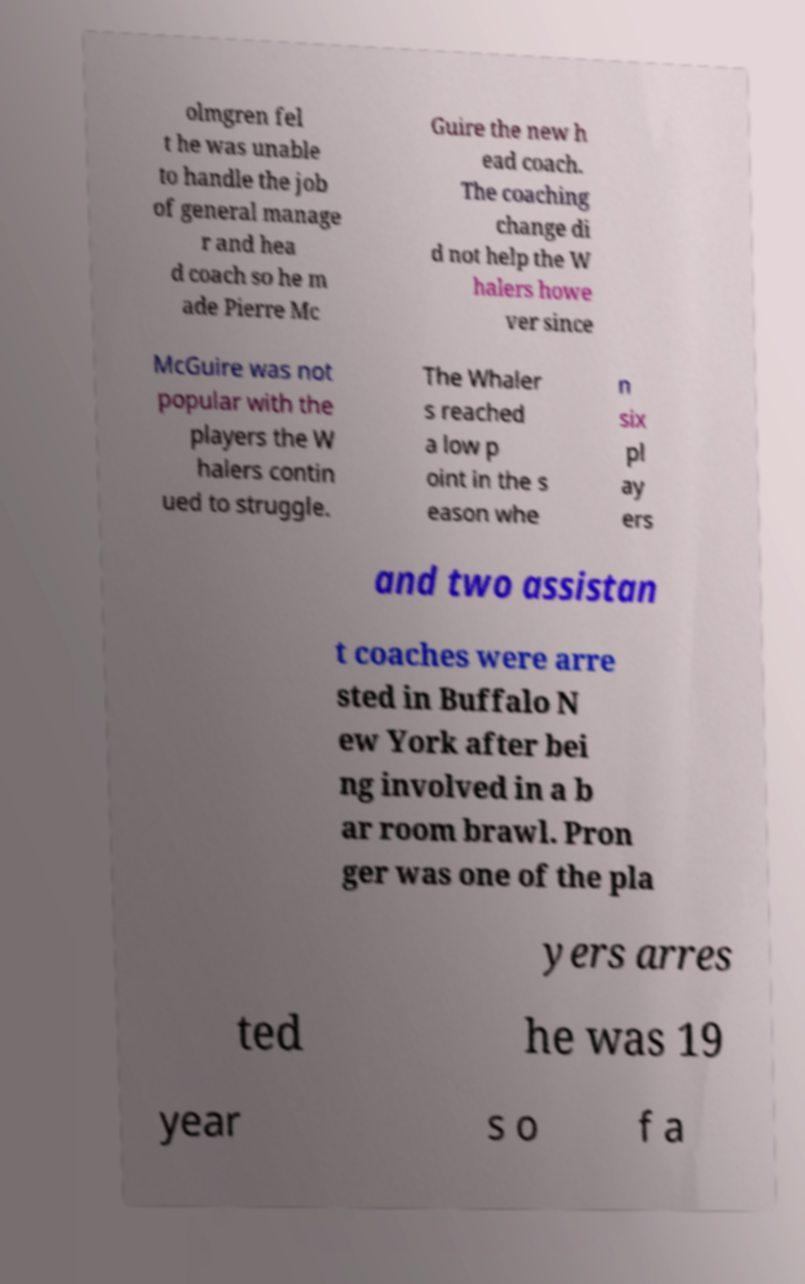Can you accurately transcribe the text from the provided image for me? olmgren fel t he was unable to handle the job of general manage r and hea d coach so he m ade Pierre Mc Guire the new h ead coach. The coaching change di d not help the W halers howe ver since McGuire was not popular with the players the W halers contin ued to struggle. The Whaler s reached a low p oint in the s eason whe n six pl ay ers and two assistan t coaches were arre sted in Buffalo N ew York after bei ng involved in a b ar room brawl. Pron ger was one of the pla yers arres ted he was 19 year s o f a 